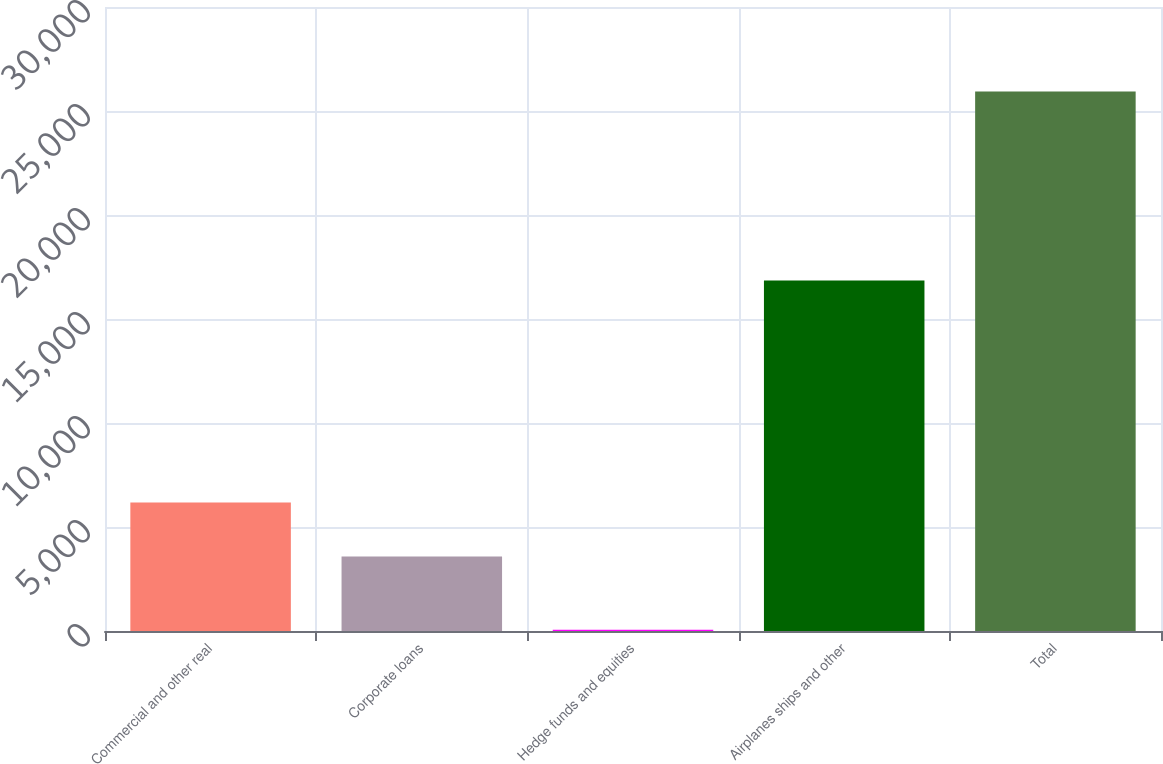<chart> <loc_0><loc_0><loc_500><loc_500><bar_chart><fcel>Commercial and other real<fcel>Corporate loans<fcel>Hedge funds and equities<fcel>Airplanes ships and other<fcel>Total<nl><fcel>6175.1<fcel>3587<fcel>58<fcel>16849<fcel>25939<nl></chart> 